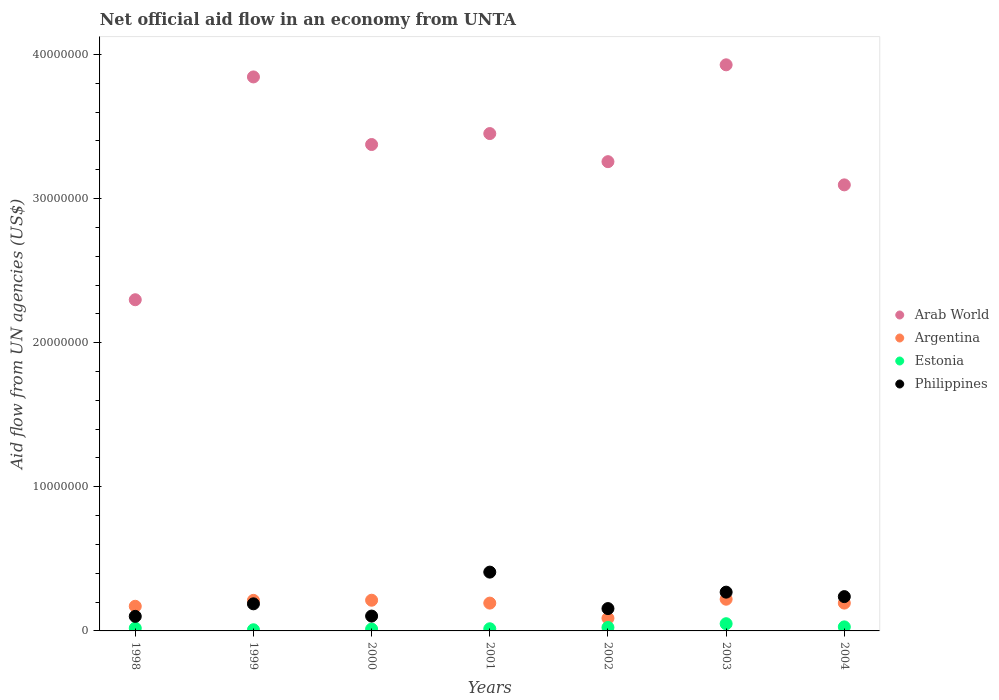Is the number of dotlines equal to the number of legend labels?
Offer a very short reply. Yes. What is the net official aid flow in Arab World in 2000?
Offer a terse response. 3.38e+07. Across all years, what is the maximum net official aid flow in Arab World?
Offer a terse response. 3.93e+07. In which year was the net official aid flow in Arab World maximum?
Ensure brevity in your answer.  2003. In which year was the net official aid flow in Estonia minimum?
Offer a terse response. 1999. What is the total net official aid flow in Argentina in the graph?
Your answer should be compact. 1.29e+07. What is the difference between the net official aid flow in Argentina in 1999 and that in 2001?
Ensure brevity in your answer.  1.90e+05. What is the difference between the net official aid flow in Philippines in 2002 and the net official aid flow in Argentina in 2003?
Make the answer very short. -6.50e+05. What is the average net official aid flow in Argentina per year?
Give a very brief answer. 1.84e+06. In the year 2000, what is the difference between the net official aid flow in Argentina and net official aid flow in Philippines?
Your response must be concise. 1.10e+06. In how many years, is the net official aid flow in Estonia greater than 6000000 US$?
Provide a short and direct response. 0. What is the ratio of the net official aid flow in Argentina in 2001 to that in 2003?
Keep it short and to the point. 0.88. Is the difference between the net official aid flow in Argentina in 1999 and 2001 greater than the difference between the net official aid flow in Philippines in 1999 and 2001?
Offer a terse response. Yes. What is the difference between the highest and the second highest net official aid flow in Philippines?
Keep it short and to the point. 1.39e+06. What is the difference between the highest and the lowest net official aid flow in Philippines?
Give a very brief answer. 3.07e+06. In how many years, is the net official aid flow in Arab World greater than the average net official aid flow in Arab World taken over all years?
Ensure brevity in your answer.  4. Is the net official aid flow in Arab World strictly greater than the net official aid flow in Argentina over the years?
Provide a short and direct response. Yes. Are the values on the major ticks of Y-axis written in scientific E-notation?
Offer a terse response. No. Does the graph contain grids?
Give a very brief answer. No. How many legend labels are there?
Provide a succinct answer. 4. What is the title of the graph?
Your answer should be compact. Net official aid flow in an economy from UNTA. What is the label or title of the Y-axis?
Make the answer very short. Aid flow from UN agencies (US$). What is the Aid flow from UN agencies (US$) of Arab World in 1998?
Provide a short and direct response. 2.30e+07. What is the Aid flow from UN agencies (US$) of Argentina in 1998?
Offer a terse response. 1.71e+06. What is the Aid flow from UN agencies (US$) of Philippines in 1998?
Ensure brevity in your answer.  1.01e+06. What is the Aid flow from UN agencies (US$) in Arab World in 1999?
Provide a succinct answer. 3.84e+07. What is the Aid flow from UN agencies (US$) in Argentina in 1999?
Your response must be concise. 2.12e+06. What is the Aid flow from UN agencies (US$) in Philippines in 1999?
Your response must be concise. 1.88e+06. What is the Aid flow from UN agencies (US$) of Arab World in 2000?
Ensure brevity in your answer.  3.38e+07. What is the Aid flow from UN agencies (US$) in Argentina in 2000?
Provide a succinct answer. 2.13e+06. What is the Aid flow from UN agencies (US$) of Philippines in 2000?
Make the answer very short. 1.03e+06. What is the Aid flow from UN agencies (US$) of Arab World in 2001?
Make the answer very short. 3.45e+07. What is the Aid flow from UN agencies (US$) in Argentina in 2001?
Provide a succinct answer. 1.93e+06. What is the Aid flow from UN agencies (US$) in Estonia in 2001?
Provide a succinct answer. 1.50e+05. What is the Aid flow from UN agencies (US$) in Philippines in 2001?
Provide a short and direct response. 4.08e+06. What is the Aid flow from UN agencies (US$) in Arab World in 2002?
Make the answer very short. 3.26e+07. What is the Aid flow from UN agencies (US$) in Argentina in 2002?
Make the answer very short. 8.80e+05. What is the Aid flow from UN agencies (US$) of Philippines in 2002?
Offer a terse response. 1.55e+06. What is the Aid flow from UN agencies (US$) of Arab World in 2003?
Offer a terse response. 3.93e+07. What is the Aid flow from UN agencies (US$) of Argentina in 2003?
Provide a short and direct response. 2.20e+06. What is the Aid flow from UN agencies (US$) in Philippines in 2003?
Provide a short and direct response. 2.69e+06. What is the Aid flow from UN agencies (US$) of Arab World in 2004?
Offer a very short reply. 3.10e+07. What is the Aid flow from UN agencies (US$) in Argentina in 2004?
Provide a succinct answer. 1.93e+06. What is the Aid flow from UN agencies (US$) in Estonia in 2004?
Offer a terse response. 2.80e+05. What is the Aid flow from UN agencies (US$) of Philippines in 2004?
Your answer should be compact. 2.38e+06. Across all years, what is the maximum Aid flow from UN agencies (US$) of Arab World?
Ensure brevity in your answer.  3.93e+07. Across all years, what is the maximum Aid flow from UN agencies (US$) in Argentina?
Make the answer very short. 2.20e+06. Across all years, what is the maximum Aid flow from UN agencies (US$) of Philippines?
Provide a short and direct response. 4.08e+06. Across all years, what is the minimum Aid flow from UN agencies (US$) in Arab World?
Your answer should be very brief. 2.30e+07. Across all years, what is the minimum Aid flow from UN agencies (US$) of Argentina?
Provide a short and direct response. 8.80e+05. Across all years, what is the minimum Aid flow from UN agencies (US$) of Estonia?
Keep it short and to the point. 8.00e+04. Across all years, what is the minimum Aid flow from UN agencies (US$) in Philippines?
Make the answer very short. 1.01e+06. What is the total Aid flow from UN agencies (US$) of Arab World in the graph?
Make the answer very short. 2.32e+08. What is the total Aid flow from UN agencies (US$) of Argentina in the graph?
Your answer should be very brief. 1.29e+07. What is the total Aid flow from UN agencies (US$) in Estonia in the graph?
Offer a very short reply. 1.57e+06. What is the total Aid flow from UN agencies (US$) of Philippines in the graph?
Provide a succinct answer. 1.46e+07. What is the difference between the Aid flow from UN agencies (US$) in Arab World in 1998 and that in 1999?
Offer a terse response. -1.55e+07. What is the difference between the Aid flow from UN agencies (US$) in Argentina in 1998 and that in 1999?
Provide a short and direct response. -4.10e+05. What is the difference between the Aid flow from UN agencies (US$) of Philippines in 1998 and that in 1999?
Your answer should be very brief. -8.70e+05. What is the difference between the Aid flow from UN agencies (US$) of Arab World in 1998 and that in 2000?
Give a very brief answer. -1.08e+07. What is the difference between the Aid flow from UN agencies (US$) of Argentina in 1998 and that in 2000?
Give a very brief answer. -4.20e+05. What is the difference between the Aid flow from UN agencies (US$) of Philippines in 1998 and that in 2000?
Keep it short and to the point. -2.00e+04. What is the difference between the Aid flow from UN agencies (US$) in Arab World in 1998 and that in 2001?
Give a very brief answer. -1.15e+07. What is the difference between the Aid flow from UN agencies (US$) of Philippines in 1998 and that in 2001?
Your answer should be very brief. -3.07e+06. What is the difference between the Aid flow from UN agencies (US$) in Arab World in 1998 and that in 2002?
Give a very brief answer. -9.58e+06. What is the difference between the Aid flow from UN agencies (US$) of Argentina in 1998 and that in 2002?
Make the answer very short. 8.30e+05. What is the difference between the Aid flow from UN agencies (US$) in Estonia in 1998 and that in 2002?
Provide a short and direct response. -5.00e+04. What is the difference between the Aid flow from UN agencies (US$) of Philippines in 1998 and that in 2002?
Keep it short and to the point. -5.40e+05. What is the difference between the Aid flow from UN agencies (US$) of Arab World in 1998 and that in 2003?
Your answer should be compact. -1.63e+07. What is the difference between the Aid flow from UN agencies (US$) of Argentina in 1998 and that in 2003?
Give a very brief answer. -4.90e+05. What is the difference between the Aid flow from UN agencies (US$) in Estonia in 1998 and that in 2003?
Your answer should be very brief. -3.10e+05. What is the difference between the Aid flow from UN agencies (US$) of Philippines in 1998 and that in 2003?
Provide a succinct answer. -1.68e+06. What is the difference between the Aid flow from UN agencies (US$) in Arab World in 1998 and that in 2004?
Keep it short and to the point. -7.97e+06. What is the difference between the Aid flow from UN agencies (US$) of Argentina in 1998 and that in 2004?
Provide a succinct answer. -2.20e+05. What is the difference between the Aid flow from UN agencies (US$) of Estonia in 1998 and that in 2004?
Give a very brief answer. -9.00e+04. What is the difference between the Aid flow from UN agencies (US$) of Philippines in 1998 and that in 2004?
Ensure brevity in your answer.  -1.37e+06. What is the difference between the Aid flow from UN agencies (US$) of Arab World in 1999 and that in 2000?
Provide a short and direct response. 4.69e+06. What is the difference between the Aid flow from UN agencies (US$) in Philippines in 1999 and that in 2000?
Offer a terse response. 8.50e+05. What is the difference between the Aid flow from UN agencies (US$) of Arab World in 1999 and that in 2001?
Offer a terse response. 3.93e+06. What is the difference between the Aid flow from UN agencies (US$) of Argentina in 1999 and that in 2001?
Provide a short and direct response. 1.90e+05. What is the difference between the Aid flow from UN agencies (US$) of Philippines in 1999 and that in 2001?
Offer a very short reply. -2.20e+06. What is the difference between the Aid flow from UN agencies (US$) in Arab World in 1999 and that in 2002?
Make the answer very short. 5.88e+06. What is the difference between the Aid flow from UN agencies (US$) in Argentina in 1999 and that in 2002?
Keep it short and to the point. 1.24e+06. What is the difference between the Aid flow from UN agencies (US$) in Estonia in 1999 and that in 2002?
Offer a terse response. -1.60e+05. What is the difference between the Aid flow from UN agencies (US$) of Arab World in 1999 and that in 2003?
Provide a succinct answer. -8.40e+05. What is the difference between the Aid flow from UN agencies (US$) in Estonia in 1999 and that in 2003?
Your answer should be very brief. -4.20e+05. What is the difference between the Aid flow from UN agencies (US$) in Philippines in 1999 and that in 2003?
Ensure brevity in your answer.  -8.10e+05. What is the difference between the Aid flow from UN agencies (US$) in Arab World in 1999 and that in 2004?
Make the answer very short. 7.49e+06. What is the difference between the Aid flow from UN agencies (US$) in Argentina in 1999 and that in 2004?
Offer a very short reply. 1.90e+05. What is the difference between the Aid flow from UN agencies (US$) in Philippines in 1999 and that in 2004?
Offer a terse response. -5.00e+05. What is the difference between the Aid flow from UN agencies (US$) in Arab World in 2000 and that in 2001?
Ensure brevity in your answer.  -7.60e+05. What is the difference between the Aid flow from UN agencies (US$) of Estonia in 2000 and that in 2001?
Offer a terse response. -2.00e+04. What is the difference between the Aid flow from UN agencies (US$) of Philippines in 2000 and that in 2001?
Offer a terse response. -3.05e+06. What is the difference between the Aid flow from UN agencies (US$) in Arab World in 2000 and that in 2002?
Keep it short and to the point. 1.19e+06. What is the difference between the Aid flow from UN agencies (US$) in Argentina in 2000 and that in 2002?
Your response must be concise. 1.25e+06. What is the difference between the Aid flow from UN agencies (US$) of Estonia in 2000 and that in 2002?
Offer a terse response. -1.10e+05. What is the difference between the Aid flow from UN agencies (US$) of Philippines in 2000 and that in 2002?
Make the answer very short. -5.20e+05. What is the difference between the Aid flow from UN agencies (US$) in Arab World in 2000 and that in 2003?
Ensure brevity in your answer.  -5.53e+06. What is the difference between the Aid flow from UN agencies (US$) of Estonia in 2000 and that in 2003?
Provide a succinct answer. -3.70e+05. What is the difference between the Aid flow from UN agencies (US$) of Philippines in 2000 and that in 2003?
Keep it short and to the point. -1.66e+06. What is the difference between the Aid flow from UN agencies (US$) in Arab World in 2000 and that in 2004?
Your response must be concise. 2.80e+06. What is the difference between the Aid flow from UN agencies (US$) in Estonia in 2000 and that in 2004?
Make the answer very short. -1.50e+05. What is the difference between the Aid flow from UN agencies (US$) of Philippines in 2000 and that in 2004?
Offer a very short reply. -1.35e+06. What is the difference between the Aid flow from UN agencies (US$) in Arab World in 2001 and that in 2002?
Your answer should be compact. 1.95e+06. What is the difference between the Aid flow from UN agencies (US$) in Argentina in 2001 and that in 2002?
Ensure brevity in your answer.  1.05e+06. What is the difference between the Aid flow from UN agencies (US$) in Philippines in 2001 and that in 2002?
Provide a short and direct response. 2.53e+06. What is the difference between the Aid flow from UN agencies (US$) in Arab World in 2001 and that in 2003?
Ensure brevity in your answer.  -4.77e+06. What is the difference between the Aid flow from UN agencies (US$) of Argentina in 2001 and that in 2003?
Make the answer very short. -2.70e+05. What is the difference between the Aid flow from UN agencies (US$) of Estonia in 2001 and that in 2003?
Provide a short and direct response. -3.50e+05. What is the difference between the Aid flow from UN agencies (US$) of Philippines in 2001 and that in 2003?
Your answer should be very brief. 1.39e+06. What is the difference between the Aid flow from UN agencies (US$) in Arab World in 2001 and that in 2004?
Provide a succinct answer. 3.56e+06. What is the difference between the Aid flow from UN agencies (US$) in Argentina in 2001 and that in 2004?
Provide a short and direct response. 0. What is the difference between the Aid flow from UN agencies (US$) of Philippines in 2001 and that in 2004?
Your answer should be compact. 1.70e+06. What is the difference between the Aid flow from UN agencies (US$) in Arab World in 2002 and that in 2003?
Make the answer very short. -6.72e+06. What is the difference between the Aid flow from UN agencies (US$) of Argentina in 2002 and that in 2003?
Ensure brevity in your answer.  -1.32e+06. What is the difference between the Aid flow from UN agencies (US$) in Estonia in 2002 and that in 2003?
Give a very brief answer. -2.60e+05. What is the difference between the Aid flow from UN agencies (US$) of Philippines in 2002 and that in 2003?
Provide a succinct answer. -1.14e+06. What is the difference between the Aid flow from UN agencies (US$) in Arab World in 2002 and that in 2004?
Your response must be concise. 1.61e+06. What is the difference between the Aid flow from UN agencies (US$) of Argentina in 2002 and that in 2004?
Offer a terse response. -1.05e+06. What is the difference between the Aid flow from UN agencies (US$) in Philippines in 2002 and that in 2004?
Ensure brevity in your answer.  -8.30e+05. What is the difference between the Aid flow from UN agencies (US$) of Arab World in 2003 and that in 2004?
Ensure brevity in your answer.  8.33e+06. What is the difference between the Aid flow from UN agencies (US$) in Estonia in 2003 and that in 2004?
Your answer should be compact. 2.20e+05. What is the difference between the Aid flow from UN agencies (US$) in Philippines in 2003 and that in 2004?
Offer a very short reply. 3.10e+05. What is the difference between the Aid flow from UN agencies (US$) in Arab World in 1998 and the Aid flow from UN agencies (US$) in Argentina in 1999?
Your response must be concise. 2.09e+07. What is the difference between the Aid flow from UN agencies (US$) of Arab World in 1998 and the Aid flow from UN agencies (US$) of Estonia in 1999?
Make the answer very short. 2.29e+07. What is the difference between the Aid flow from UN agencies (US$) in Arab World in 1998 and the Aid flow from UN agencies (US$) in Philippines in 1999?
Your response must be concise. 2.11e+07. What is the difference between the Aid flow from UN agencies (US$) of Argentina in 1998 and the Aid flow from UN agencies (US$) of Estonia in 1999?
Your response must be concise. 1.63e+06. What is the difference between the Aid flow from UN agencies (US$) in Argentina in 1998 and the Aid flow from UN agencies (US$) in Philippines in 1999?
Give a very brief answer. -1.70e+05. What is the difference between the Aid flow from UN agencies (US$) in Estonia in 1998 and the Aid flow from UN agencies (US$) in Philippines in 1999?
Make the answer very short. -1.69e+06. What is the difference between the Aid flow from UN agencies (US$) in Arab World in 1998 and the Aid flow from UN agencies (US$) in Argentina in 2000?
Your answer should be very brief. 2.08e+07. What is the difference between the Aid flow from UN agencies (US$) in Arab World in 1998 and the Aid flow from UN agencies (US$) in Estonia in 2000?
Your answer should be compact. 2.28e+07. What is the difference between the Aid flow from UN agencies (US$) of Arab World in 1998 and the Aid flow from UN agencies (US$) of Philippines in 2000?
Your answer should be compact. 2.20e+07. What is the difference between the Aid flow from UN agencies (US$) of Argentina in 1998 and the Aid flow from UN agencies (US$) of Estonia in 2000?
Your response must be concise. 1.58e+06. What is the difference between the Aid flow from UN agencies (US$) of Argentina in 1998 and the Aid flow from UN agencies (US$) of Philippines in 2000?
Your answer should be compact. 6.80e+05. What is the difference between the Aid flow from UN agencies (US$) of Estonia in 1998 and the Aid flow from UN agencies (US$) of Philippines in 2000?
Make the answer very short. -8.40e+05. What is the difference between the Aid flow from UN agencies (US$) in Arab World in 1998 and the Aid flow from UN agencies (US$) in Argentina in 2001?
Offer a very short reply. 2.10e+07. What is the difference between the Aid flow from UN agencies (US$) of Arab World in 1998 and the Aid flow from UN agencies (US$) of Estonia in 2001?
Keep it short and to the point. 2.28e+07. What is the difference between the Aid flow from UN agencies (US$) of Arab World in 1998 and the Aid flow from UN agencies (US$) of Philippines in 2001?
Give a very brief answer. 1.89e+07. What is the difference between the Aid flow from UN agencies (US$) in Argentina in 1998 and the Aid flow from UN agencies (US$) in Estonia in 2001?
Keep it short and to the point. 1.56e+06. What is the difference between the Aid flow from UN agencies (US$) in Argentina in 1998 and the Aid flow from UN agencies (US$) in Philippines in 2001?
Your response must be concise. -2.37e+06. What is the difference between the Aid flow from UN agencies (US$) in Estonia in 1998 and the Aid flow from UN agencies (US$) in Philippines in 2001?
Your response must be concise. -3.89e+06. What is the difference between the Aid flow from UN agencies (US$) in Arab World in 1998 and the Aid flow from UN agencies (US$) in Argentina in 2002?
Keep it short and to the point. 2.21e+07. What is the difference between the Aid flow from UN agencies (US$) of Arab World in 1998 and the Aid flow from UN agencies (US$) of Estonia in 2002?
Provide a succinct answer. 2.27e+07. What is the difference between the Aid flow from UN agencies (US$) of Arab World in 1998 and the Aid flow from UN agencies (US$) of Philippines in 2002?
Offer a terse response. 2.14e+07. What is the difference between the Aid flow from UN agencies (US$) of Argentina in 1998 and the Aid flow from UN agencies (US$) of Estonia in 2002?
Give a very brief answer. 1.47e+06. What is the difference between the Aid flow from UN agencies (US$) of Estonia in 1998 and the Aid flow from UN agencies (US$) of Philippines in 2002?
Give a very brief answer. -1.36e+06. What is the difference between the Aid flow from UN agencies (US$) in Arab World in 1998 and the Aid flow from UN agencies (US$) in Argentina in 2003?
Your answer should be very brief. 2.08e+07. What is the difference between the Aid flow from UN agencies (US$) of Arab World in 1998 and the Aid flow from UN agencies (US$) of Estonia in 2003?
Your response must be concise. 2.25e+07. What is the difference between the Aid flow from UN agencies (US$) of Arab World in 1998 and the Aid flow from UN agencies (US$) of Philippines in 2003?
Provide a succinct answer. 2.03e+07. What is the difference between the Aid flow from UN agencies (US$) in Argentina in 1998 and the Aid flow from UN agencies (US$) in Estonia in 2003?
Keep it short and to the point. 1.21e+06. What is the difference between the Aid flow from UN agencies (US$) in Argentina in 1998 and the Aid flow from UN agencies (US$) in Philippines in 2003?
Your answer should be very brief. -9.80e+05. What is the difference between the Aid flow from UN agencies (US$) in Estonia in 1998 and the Aid flow from UN agencies (US$) in Philippines in 2003?
Your answer should be very brief. -2.50e+06. What is the difference between the Aid flow from UN agencies (US$) in Arab World in 1998 and the Aid flow from UN agencies (US$) in Argentina in 2004?
Keep it short and to the point. 2.10e+07. What is the difference between the Aid flow from UN agencies (US$) in Arab World in 1998 and the Aid flow from UN agencies (US$) in Estonia in 2004?
Offer a very short reply. 2.27e+07. What is the difference between the Aid flow from UN agencies (US$) in Arab World in 1998 and the Aid flow from UN agencies (US$) in Philippines in 2004?
Your answer should be compact. 2.06e+07. What is the difference between the Aid flow from UN agencies (US$) in Argentina in 1998 and the Aid flow from UN agencies (US$) in Estonia in 2004?
Give a very brief answer. 1.43e+06. What is the difference between the Aid flow from UN agencies (US$) of Argentina in 1998 and the Aid flow from UN agencies (US$) of Philippines in 2004?
Offer a terse response. -6.70e+05. What is the difference between the Aid flow from UN agencies (US$) of Estonia in 1998 and the Aid flow from UN agencies (US$) of Philippines in 2004?
Your answer should be very brief. -2.19e+06. What is the difference between the Aid flow from UN agencies (US$) of Arab World in 1999 and the Aid flow from UN agencies (US$) of Argentina in 2000?
Make the answer very short. 3.63e+07. What is the difference between the Aid flow from UN agencies (US$) of Arab World in 1999 and the Aid flow from UN agencies (US$) of Estonia in 2000?
Provide a short and direct response. 3.83e+07. What is the difference between the Aid flow from UN agencies (US$) of Arab World in 1999 and the Aid flow from UN agencies (US$) of Philippines in 2000?
Your answer should be very brief. 3.74e+07. What is the difference between the Aid flow from UN agencies (US$) in Argentina in 1999 and the Aid flow from UN agencies (US$) in Estonia in 2000?
Your answer should be compact. 1.99e+06. What is the difference between the Aid flow from UN agencies (US$) in Argentina in 1999 and the Aid flow from UN agencies (US$) in Philippines in 2000?
Keep it short and to the point. 1.09e+06. What is the difference between the Aid flow from UN agencies (US$) in Estonia in 1999 and the Aid flow from UN agencies (US$) in Philippines in 2000?
Offer a very short reply. -9.50e+05. What is the difference between the Aid flow from UN agencies (US$) in Arab World in 1999 and the Aid flow from UN agencies (US$) in Argentina in 2001?
Provide a succinct answer. 3.65e+07. What is the difference between the Aid flow from UN agencies (US$) of Arab World in 1999 and the Aid flow from UN agencies (US$) of Estonia in 2001?
Your answer should be very brief. 3.83e+07. What is the difference between the Aid flow from UN agencies (US$) in Arab World in 1999 and the Aid flow from UN agencies (US$) in Philippines in 2001?
Offer a very short reply. 3.44e+07. What is the difference between the Aid flow from UN agencies (US$) of Argentina in 1999 and the Aid flow from UN agencies (US$) of Estonia in 2001?
Offer a very short reply. 1.97e+06. What is the difference between the Aid flow from UN agencies (US$) of Argentina in 1999 and the Aid flow from UN agencies (US$) of Philippines in 2001?
Offer a terse response. -1.96e+06. What is the difference between the Aid flow from UN agencies (US$) of Arab World in 1999 and the Aid flow from UN agencies (US$) of Argentina in 2002?
Provide a succinct answer. 3.76e+07. What is the difference between the Aid flow from UN agencies (US$) of Arab World in 1999 and the Aid flow from UN agencies (US$) of Estonia in 2002?
Offer a terse response. 3.82e+07. What is the difference between the Aid flow from UN agencies (US$) of Arab World in 1999 and the Aid flow from UN agencies (US$) of Philippines in 2002?
Ensure brevity in your answer.  3.69e+07. What is the difference between the Aid flow from UN agencies (US$) of Argentina in 1999 and the Aid flow from UN agencies (US$) of Estonia in 2002?
Provide a short and direct response. 1.88e+06. What is the difference between the Aid flow from UN agencies (US$) of Argentina in 1999 and the Aid flow from UN agencies (US$) of Philippines in 2002?
Ensure brevity in your answer.  5.70e+05. What is the difference between the Aid flow from UN agencies (US$) of Estonia in 1999 and the Aid flow from UN agencies (US$) of Philippines in 2002?
Give a very brief answer. -1.47e+06. What is the difference between the Aid flow from UN agencies (US$) of Arab World in 1999 and the Aid flow from UN agencies (US$) of Argentina in 2003?
Make the answer very short. 3.62e+07. What is the difference between the Aid flow from UN agencies (US$) in Arab World in 1999 and the Aid flow from UN agencies (US$) in Estonia in 2003?
Your answer should be compact. 3.79e+07. What is the difference between the Aid flow from UN agencies (US$) in Arab World in 1999 and the Aid flow from UN agencies (US$) in Philippines in 2003?
Offer a terse response. 3.58e+07. What is the difference between the Aid flow from UN agencies (US$) of Argentina in 1999 and the Aid flow from UN agencies (US$) of Estonia in 2003?
Your answer should be very brief. 1.62e+06. What is the difference between the Aid flow from UN agencies (US$) in Argentina in 1999 and the Aid flow from UN agencies (US$) in Philippines in 2003?
Keep it short and to the point. -5.70e+05. What is the difference between the Aid flow from UN agencies (US$) in Estonia in 1999 and the Aid flow from UN agencies (US$) in Philippines in 2003?
Your response must be concise. -2.61e+06. What is the difference between the Aid flow from UN agencies (US$) in Arab World in 1999 and the Aid flow from UN agencies (US$) in Argentina in 2004?
Your answer should be compact. 3.65e+07. What is the difference between the Aid flow from UN agencies (US$) of Arab World in 1999 and the Aid flow from UN agencies (US$) of Estonia in 2004?
Provide a succinct answer. 3.82e+07. What is the difference between the Aid flow from UN agencies (US$) of Arab World in 1999 and the Aid flow from UN agencies (US$) of Philippines in 2004?
Ensure brevity in your answer.  3.61e+07. What is the difference between the Aid flow from UN agencies (US$) of Argentina in 1999 and the Aid flow from UN agencies (US$) of Estonia in 2004?
Ensure brevity in your answer.  1.84e+06. What is the difference between the Aid flow from UN agencies (US$) of Argentina in 1999 and the Aid flow from UN agencies (US$) of Philippines in 2004?
Your answer should be very brief. -2.60e+05. What is the difference between the Aid flow from UN agencies (US$) of Estonia in 1999 and the Aid flow from UN agencies (US$) of Philippines in 2004?
Keep it short and to the point. -2.30e+06. What is the difference between the Aid flow from UN agencies (US$) of Arab World in 2000 and the Aid flow from UN agencies (US$) of Argentina in 2001?
Give a very brief answer. 3.18e+07. What is the difference between the Aid flow from UN agencies (US$) in Arab World in 2000 and the Aid flow from UN agencies (US$) in Estonia in 2001?
Offer a terse response. 3.36e+07. What is the difference between the Aid flow from UN agencies (US$) in Arab World in 2000 and the Aid flow from UN agencies (US$) in Philippines in 2001?
Your answer should be very brief. 2.97e+07. What is the difference between the Aid flow from UN agencies (US$) in Argentina in 2000 and the Aid flow from UN agencies (US$) in Estonia in 2001?
Ensure brevity in your answer.  1.98e+06. What is the difference between the Aid flow from UN agencies (US$) in Argentina in 2000 and the Aid flow from UN agencies (US$) in Philippines in 2001?
Provide a short and direct response. -1.95e+06. What is the difference between the Aid flow from UN agencies (US$) in Estonia in 2000 and the Aid flow from UN agencies (US$) in Philippines in 2001?
Your answer should be compact. -3.95e+06. What is the difference between the Aid flow from UN agencies (US$) of Arab World in 2000 and the Aid flow from UN agencies (US$) of Argentina in 2002?
Ensure brevity in your answer.  3.29e+07. What is the difference between the Aid flow from UN agencies (US$) in Arab World in 2000 and the Aid flow from UN agencies (US$) in Estonia in 2002?
Offer a very short reply. 3.35e+07. What is the difference between the Aid flow from UN agencies (US$) of Arab World in 2000 and the Aid flow from UN agencies (US$) of Philippines in 2002?
Offer a very short reply. 3.22e+07. What is the difference between the Aid flow from UN agencies (US$) in Argentina in 2000 and the Aid flow from UN agencies (US$) in Estonia in 2002?
Offer a very short reply. 1.89e+06. What is the difference between the Aid flow from UN agencies (US$) of Argentina in 2000 and the Aid flow from UN agencies (US$) of Philippines in 2002?
Provide a succinct answer. 5.80e+05. What is the difference between the Aid flow from UN agencies (US$) in Estonia in 2000 and the Aid flow from UN agencies (US$) in Philippines in 2002?
Your answer should be compact. -1.42e+06. What is the difference between the Aid flow from UN agencies (US$) in Arab World in 2000 and the Aid flow from UN agencies (US$) in Argentina in 2003?
Your answer should be compact. 3.16e+07. What is the difference between the Aid flow from UN agencies (US$) in Arab World in 2000 and the Aid flow from UN agencies (US$) in Estonia in 2003?
Offer a very short reply. 3.32e+07. What is the difference between the Aid flow from UN agencies (US$) in Arab World in 2000 and the Aid flow from UN agencies (US$) in Philippines in 2003?
Provide a succinct answer. 3.11e+07. What is the difference between the Aid flow from UN agencies (US$) of Argentina in 2000 and the Aid flow from UN agencies (US$) of Estonia in 2003?
Give a very brief answer. 1.63e+06. What is the difference between the Aid flow from UN agencies (US$) in Argentina in 2000 and the Aid flow from UN agencies (US$) in Philippines in 2003?
Your answer should be very brief. -5.60e+05. What is the difference between the Aid flow from UN agencies (US$) of Estonia in 2000 and the Aid flow from UN agencies (US$) of Philippines in 2003?
Provide a succinct answer. -2.56e+06. What is the difference between the Aid flow from UN agencies (US$) of Arab World in 2000 and the Aid flow from UN agencies (US$) of Argentina in 2004?
Give a very brief answer. 3.18e+07. What is the difference between the Aid flow from UN agencies (US$) of Arab World in 2000 and the Aid flow from UN agencies (US$) of Estonia in 2004?
Provide a short and direct response. 3.35e+07. What is the difference between the Aid flow from UN agencies (US$) in Arab World in 2000 and the Aid flow from UN agencies (US$) in Philippines in 2004?
Your response must be concise. 3.14e+07. What is the difference between the Aid flow from UN agencies (US$) of Argentina in 2000 and the Aid flow from UN agencies (US$) of Estonia in 2004?
Ensure brevity in your answer.  1.85e+06. What is the difference between the Aid flow from UN agencies (US$) of Estonia in 2000 and the Aid flow from UN agencies (US$) of Philippines in 2004?
Give a very brief answer. -2.25e+06. What is the difference between the Aid flow from UN agencies (US$) in Arab World in 2001 and the Aid flow from UN agencies (US$) in Argentina in 2002?
Offer a very short reply. 3.36e+07. What is the difference between the Aid flow from UN agencies (US$) in Arab World in 2001 and the Aid flow from UN agencies (US$) in Estonia in 2002?
Your answer should be compact. 3.43e+07. What is the difference between the Aid flow from UN agencies (US$) of Arab World in 2001 and the Aid flow from UN agencies (US$) of Philippines in 2002?
Offer a terse response. 3.30e+07. What is the difference between the Aid flow from UN agencies (US$) in Argentina in 2001 and the Aid flow from UN agencies (US$) in Estonia in 2002?
Offer a very short reply. 1.69e+06. What is the difference between the Aid flow from UN agencies (US$) of Estonia in 2001 and the Aid flow from UN agencies (US$) of Philippines in 2002?
Make the answer very short. -1.40e+06. What is the difference between the Aid flow from UN agencies (US$) of Arab World in 2001 and the Aid flow from UN agencies (US$) of Argentina in 2003?
Provide a succinct answer. 3.23e+07. What is the difference between the Aid flow from UN agencies (US$) in Arab World in 2001 and the Aid flow from UN agencies (US$) in Estonia in 2003?
Your answer should be very brief. 3.40e+07. What is the difference between the Aid flow from UN agencies (US$) of Arab World in 2001 and the Aid flow from UN agencies (US$) of Philippines in 2003?
Provide a succinct answer. 3.18e+07. What is the difference between the Aid flow from UN agencies (US$) in Argentina in 2001 and the Aid flow from UN agencies (US$) in Estonia in 2003?
Keep it short and to the point. 1.43e+06. What is the difference between the Aid flow from UN agencies (US$) of Argentina in 2001 and the Aid flow from UN agencies (US$) of Philippines in 2003?
Provide a succinct answer. -7.60e+05. What is the difference between the Aid flow from UN agencies (US$) of Estonia in 2001 and the Aid flow from UN agencies (US$) of Philippines in 2003?
Keep it short and to the point. -2.54e+06. What is the difference between the Aid flow from UN agencies (US$) in Arab World in 2001 and the Aid flow from UN agencies (US$) in Argentina in 2004?
Keep it short and to the point. 3.26e+07. What is the difference between the Aid flow from UN agencies (US$) of Arab World in 2001 and the Aid flow from UN agencies (US$) of Estonia in 2004?
Ensure brevity in your answer.  3.42e+07. What is the difference between the Aid flow from UN agencies (US$) of Arab World in 2001 and the Aid flow from UN agencies (US$) of Philippines in 2004?
Offer a terse response. 3.21e+07. What is the difference between the Aid flow from UN agencies (US$) of Argentina in 2001 and the Aid flow from UN agencies (US$) of Estonia in 2004?
Provide a short and direct response. 1.65e+06. What is the difference between the Aid flow from UN agencies (US$) in Argentina in 2001 and the Aid flow from UN agencies (US$) in Philippines in 2004?
Provide a succinct answer. -4.50e+05. What is the difference between the Aid flow from UN agencies (US$) of Estonia in 2001 and the Aid flow from UN agencies (US$) of Philippines in 2004?
Give a very brief answer. -2.23e+06. What is the difference between the Aid flow from UN agencies (US$) of Arab World in 2002 and the Aid flow from UN agencies (US$) of Argentina in 2003?
Offer a very short reply. 3.04e+07. What is the difference between the Aid flow from UN agencies (US$) of Arab World in 2002 and the Aid flow from UN agencies (US$) of Estonia in 2003?
Make the answer very short. 3.21e+07. What is the difference between the Aid flow from UN agencies (US$) in Arab World in 2002 and the Aid flow from UN agencies (US$) in Philippines in 2003?
Your response must be concise. 2.99e+07. What is the difference between the Aid flow from UN agencies (US$) of Argentina in 2002 and the Aid flow from UN agencies (US$) of Estonia in 2003?
Offer a terse response. 3.80e+05. What is the difference between the Aid flow from UN agencies (US$) of Argentina in 2002 and the Aid flow from UN agencies (US$) of Philippines in 2003?
Your response must be concise. -1.81e+06. What is the difference between the Aid flow from UN agencies (US$) in Estonia in 2002 and the Aid flow from UN agencies (US$) in Philippines in 2003?
Offer a terse response. -2.45e+06. What is the difference between the Aid flow from UN agencies (US$) in Arab World in 2002 and the Aid flow from UN agencies (US$) in Argentina in 2004?
Offer a terse response. 3.06e+07. What is the difference between the Aid flow from UN agencies (US$) of Arab World in 2002 and the Aid flow from UN agencies (US$) of Estonia in 2004?
Ensure brevity in your answer.  3.23e+07. What is the difference between the Aid flow from UN agencies (US$) of Arab World in 2002 and the Aid flow from UN agencies (US$) of Philippines in 2004?
Your response must be concise. 3.02e+07. What is the difference between the Aid flow from UN agencies (US$) of Argentina in 2002 and the Aid flow from UN agencies (US$) of Estonia in 2004?
Ensure brevity in your answer.  6.00e+05. What is the difference between the Aid flow from UN agencies (US$) of Argentina in 2002 and the Aid flow from UN agencies (US$) of Philippines in 2004?
Provide a short and direct response. -1.50e+06. What is the difference between the Aid flow from UN agencies (US$) in Estonia in 2002 and the Aid flow from UN agencies (US$) in Philippines in 2004?
Give a very brief answer. -2.14e+06. What is the difference between the Aid flow from UN agencies (US$) in Arab World in 2003 and the Aid flow from UN agencies (US$) in Argentina in 2004?
Offer a terse response. 3.74e+07. What is the difference between the Aid flow from UN agencies (US$) of Arab World in 2003 and the Aid flow from UN agencies (US$) of Estonia in 2004?
Your answer should be compact. 3.90e+07. What is the difference between the Aid flow from UN agencies (US$) in Arab World in 2003 and the Aid flow from UN agencies (US$) in Philippines in 2004?
Keep it short and to the point. 3.69e+07. What is the difference between the Aid flow from UN agencies (US$) in Argentina in 2003 and the Aid flow from UN agencies (US$) in Estonia in 2004?
Your response must be concise. 1.92e+06. What is the difference between the Aid flow from UN agencies (US$) of Argentina in 2003 and the Aid flow from UN agencies (US$) of Philippines in 2004?
Your answer should be very brief. -1.80e+05. What is the difference between the Aid flow from UN agencies (US$) in Estonia in 2003 and the Aid flow from UN agencies (US$) in Philippines in 2004?
Make the answer very short. -1.88e+06. What is the average Aid flow from UN agencies (US$) in Arab World per year?
Your answer should be compact. 3.32e+07. What is the average Aid flow from UN agencies (US$) of Argentina per year?
Offer a terse response. 1.84e+06. What is the average Aid flow from UN agencies (US$) in Estonia per year?
Make the answer very short. 2.24e+05. What is the average Aid flow from UN agencies (US$) of Philippines per year?
Your answer should be compact. 2.09e+06. In the year 1998, what is the difference between the Aid flow from UN agencies (US$) in Arab World and Aid flow from UN agencies (US$) in Argentina?
Provide a short and direct response. 2.13e+07. In the year 1998, what is the difference between the Aid flow from UN agencies (US$) of Arab World and Aid flow from UN agencies (US$) of Estonia?
Make the answer very short. 2.28e+07. In the year 1998, what is the difference between the Aid flow from UN agencies (US$) in Arab World and Aid flow from UN agencies (US$) in Philippines?
Provide a short and direct response. 2.20e+07. In the year 1998, what is the difference between the Aid flow from UN agencies (US$) in Argentina and Aid flow from UN agencies (US$) in Estonia?
Offer a very short reply. 1.52e+06. In the year 1998, what is the difference between the Aid flow from UN agencies (US$) in Argentina and Aid flow from UN agencies (US$) in Philippines?
Make the answer very short. 7.00e+05. In the year 1998, what is the difference between the Aid flow from UN agencies (US$) of Estonia and Aid flow from UN agencies (US$) of Philippines?
Your answer should be very brief. -8.20e+05. In the year 1999, what is the difference between the Aid flow from UN agencies (US$) of Arab World and Aid flow from UN agencies (US$) of Argentina?
Make the answer very short. 3.63e+07. In the year 1999, what is the difference between the Aid flow from UN agencies (US$) of Arab World and Aid flow from UN agencies (US$) of Estonia?
Provide a succinct answer. 3.84e+07. In the year 1999, what is the difference between the Aid flow from UN agencies (US$) in Arab World and Aid flow from UN agencies (US$) in Philippines?
Give a very brief answer. 3.66e+07. In the year 1999, what is the difference between the Aid flow from UN agencies (US$) in Argentina and Aid flow from UN agencies (US$) in Estonia?
Your response must be concise. 2.04e+06. In the year 1999, what is the difference between the Aid flow from UN agencies (US$) in Argentina and Aid flow from UN agencies (US$) in Philippines?
Make the answer very short. 2.40e+05. In the year 1999, what is the difference between the Aid flow from UN agencies (US$) of Estonia and Aid flow from UN agencies (US$) of Philippines?
Provide a short and direct response. -1.80e+06. In the year 2000, what is the difference between the Aid flow from UN agencies (US$) of Arab World and Aid flow from UN agencies (US$) of Argentina?
Keep it short and to the point. 3.16e+07. In the year 2000, what is the difference between the Aid flow from UN agencies (US$) of Arab World and Aid flow from UN agencies (US$) of Estonia?
Keep it short and to the point. 3.36e+07. In the year 2000, what is the difference between the Aid flow from UN agencies (US$) of Arab World and Aid flow from UN agencies (US$) of Philippines?
Make the answer very short. 3.27e+07. In the year 2000, what is the difference between the Aid flow from UN agencies (US$) of Argentina and Aid flow from UN agencies (US$) of Philippines?
Give a very brief answer. 1.10e+06. In the year 2000, what is the difference between the Aid flow from UN agencies (US$) in Estonia and Aid flow from UN agencies (US$) in Philippines?
Ensure brevity in your answer.  -9.00e+05. In the year 2001, what is the difference between the Aid flow from UN agencies (US$) of Arab World and Aid flow from UN agencies (US$) of Argentina?
Offer a terse response. 3.26e+07. In the year 2001, what is the difference between the Aid flow from UN agencies (US$) of Arab World and Aid flow from UN agencies (US$) of Estonia?
Your answer should be compact. 3.44e+07. In the year 2001, what is the difference between the Aid flow from UN agencies (US$) of Arab World and Aid flow from UN agencies (US$) of Philippines?
Provide a succinct answer. 3.04e+07. In the year 2001, what is the difference between the Aid flow from UN agencies (US$) in Argentina and Aid flow from UN agencies (US$) in Estonia?
Your answer should be compact. 1.78e+06. In the year 2001, what is the difference between the Aid flow from UN agencies (US$) in Argentina and Aid flow from UN agencies (US$) in Philippines?
Provide a succinct answer. -2.15e+06. In the year 2001, what is the difference between the Aid flow from UN agencies (US$) in Estonia and Aid flow from UN agencies (US$) in Philippines?
Keep it short and to the point. -3.93e+06. In the year 2002, what is the difference between the Aid flow from UN agencies (US$) in Arab World and Aid flow from UN agencies (US$) in Argentina?
Your answer should be compact. 3.17e+07. In the year 2002, what is the difference between the Aid flow from UN agencies (US$) in Arab World and Aid flow from UN agencies (US$) in Estonia?
Your answer should be compact. 3.23e+07. In the year 2002, what is the difference between the Aid flow from UN agencies (US$) in Arab World and Aid flow from UN agencies (US$) in Philippines?
Make the answer very short. 3.10e+07. In the year 2002, what is the difference between the Aid flow from UN agencies (US$) of Argentina and Aid flow from UN agencies (US$) of Estonia?
Offer a terse response. 6.40e+05. In the year 2002, what is the difference between the Aid flow from UN agencies (US$) in Argentina and Aid flow from UN agencies (US$) in Philippines?
Your answer should be compact. -6.70e+05. In the year 2002, what is the difference between the Aid flow from UN agencies (US$) of Estonia and Aid flow from UN agencies (US$) of Philippines?
Your response must be concise. -1.31e+06. In the year 2003, what is the difference between the Aid flow from UN agencies (US$) of Arab World and Aid flow from UN agencies (US$) of Argentina?
Offer a terse response. 3.71e+07. In the year 2003, what is the difference between the Aid flow from UN agencies (US$) of Arab World and Aid flow from UN agencies (US$) of Estonia?
Your answer should be very brief. 3.88e+07. In the year 2003, what is the difference between the Aid flow from UN agencies (US$) of Arab World and Aid flow from UN agencies (US$) of Philippines?
Offer a very short reply. 3.66e+07. In the year 2003, what is the difference between the Aid flow from UN agencies (US$) in Argentina and Aid flow from UN agencies (US$) in Estonia?
Provide a short and direct response. 1.70e+06. In the year 2003, what is the difference between the Aid flow from UN agencies (US$) of Argentina and Aid flow from UN agencies (US$) of Philippines?
Ensure brevity in your answer.  -4.90e+05. In the year 2003, what is the difference between the Aid flow from UN agencies (US$) in Estonia and Aid flow from UN agencies (US$) in Philippines?
Your response must be concise. -2.19e+06. In the year 2004, what is the difference between the Aid flow from UN agencies (US$) of Arab World and Aid flow from UN agencies (US$) of Argentina?
Offer a very short reply. 2.90e+07. In the year 2004, what is the difference between the Aid flow from UN agencies (US$) of Arab World and Aid flow from UN agencies (US$) of Estonia?
Offer a very short reply. 3.07e+07. In the year 2004, what is the difference between the Aid flow from UN agencies (US$) in Arab World and Aid flow from UN agencies (US$) in Philippines?
Give a very brief answer. 2.86e+07. In the year 2004, what is the difference between the Aid flow from UN agencies (US$) of Argentina and Aid flow from UN agencies (US$) of Estonia?
Your response must be concise. 1.65e+06. In the year 2004, what is the difference between the Aid flow from UN agencies (US$) of Argentina and Aid flow from UN agencies (US$) of Philippines?
Give a very brief answer. -4.50e+05. In the year 2004, what is the difference between the Aid flow from UN agencies (US$) in Estonia and Aid flow from UN agencies (US$) in Philippines?
Your response must be concise. -2.10e+06. What is the ratio of the Aid flow from UN agencies (US$) in Arab World in 1998 to that in 1999?
Make the answer very short. 0.6. What is the ratio of the Aid flow from UN agencies (US$) in Argentina in 1998 to that in 1999?
Make the answer very short. 0.81. What is the ratio of the Aid flow from UN agencies (US$) of Estonia in 1998 to that in 1999?
Offer a terse response. 2.38. What is the ratio of the Aid flow from UN agencies (US$) in Philippines in 1998 to that in 1999?
Your answer should be very brief. 0.54. What is the ratio of the Aid flow from UN agencies (US$) in Arab World in 1998 to that in 2000?
Ensure brevity in your answer.  0.68. What is the ratio of the Aid flow from UN agencies (US$) of Argentina in 1998 to that in 2000?
Make the answer very short. 0.8. What is the ratio of the Aid flow from UN agencies (US$) of Estonia in 1998 to that in 2000?
Your response must be concise. 1.46. What is the ratio of the Aid flow from UN agencies (US$) of Philippines in 1998 to that in 2000?
Keep it short and to the point. 0.98. What is the ratio of the Aid flow from UN agencies (US$) of Arab World in 1998 to that in 2001?
Your response must be concise. 0.67. What is the ratio of the Aid flow from UN agencies (US$) in Argentina in 1998 to that in 2001?
Make the answer very short. 0.89. What is the ratio of the Aid flow from UN agencies (US$) in Estonia in 1998 to that in 2001?
Provide a short and direct response. 1.27. What is the ratio of the Aid flow from UN agencies (US$) in Philippines in 1998 to that in 2001?
Provide a succinct answer. 0.25. What is the ratio of the Aid flow from UN agencies (US$) of Arab World in 1998 to that in 2002?
Provide a succinct answer. 0.71. What is the ratio of the Aid flow from UN agencies (US$) of Argentina in 1998 to that in 2002?
Offer a terse response. 1.94. What is the ratio of the Aid flow from UN agencies (US$) of Estonia in 1998 to that in 2002?
Your answer should be very brief. 0.79. What is the ratio of the Aid flow from UN agencies (US$) in Philippines in 1998 to that in 2002?
Your answer should be very brief. 0.65. What is the ratio of the Aid flow from UN agencies (US$) in Arab World in 1998 to that in 2003?
Provide a succinct answer. 0.58. What is the ratio of the Aid flow from UN agencies (US$) of Argentina in 1998 to that in 2003?
Your answer should be compact. 0.78. What is the ratio of the Aid flow from UN agencies (US$) of Estonia in 1998 to that in 2003?
Your answer should be compact. 0.38. What is the ratio of the Aid flow from UN agencies (US$) of Philippines in 1998 to that in 2003?
Give a very brief answer. 0.38. What is the ratio of the Aid flow from UN agencies (US$) in Arab World in 1998 to that in 2004?
Offer a very short reply. 0.74. What is the ratio of the Aid flow from UN agencies (US$) in Argentina in 1998 to that in 2004?
Make the answer very short. 0.89. What is the ratio of the Aid flow from UN agencies (US$) of Estonia in 1998 to that in 2004?
Your answer should be compact. 0.68. What is the ratio of the Aid flow from UN agencies (US$) of Philippines in 1998 to that in 2004?
Give a very brief answer. 0.42. What is the ratio of the Aid flow from UN agencies (US$) in Arab World in 1999 to that in 2000?
Ensure brevity in your answer.  1.14. What is the ratio of the Aid flow from UN agencies (US$) of Argentina in 1999 to that in 2000?
Offer a terse response. 1. What is the ratio of the Aid flow from UN agencies (US$) of Estonia in 1999 to that in 2000?
Provide a short and direct response. 0.62. What is the ratio of the Aid flow from UN agencies (US$) of Philippines in 1999 to that in 2000?
Make the answer very short. 1.83. What is the ratio of the Aid flow from UN agencies (US$) in Arab World in 1999 to that in 2001?
Your response must be concise. 1.11. What is the ratio of the Aid flow from UN agencies (US$) in Argentina in 1999 to that in 2001?
Your response must be concise. 1.1. What is the ratio of the Aid flow from UN agencies (US$) in Estonia in 1999 to that in 2001?
Keep it short and to the point. 0.53. What is the ratio of the Aid flow from UN agencies (US$) in Philippines in 1999 to that in 2001?
Make the answer very short. 0.46. What is the ratio of the Aid flow from UN agencies (US$) in Arab World in 1999 to that in 2002?
Your response must be concise. 1.18. What is the ratio of the Aid flow from UN agencies (US$) of Argentina in 1999 to that in 2002?
Offer a terse response. 2.41. What is the ratio of the Aid flow from UN agencies (US$) of Estonia in 1999 to that in 2002?
Provide a succinct answer. 0.33. What is the ratio of the Aid flow from UN agencies (US$) in Philippines in 1999 to that in 2002?
Offer a very short reply. 1.21. What is the ratio of the Aid flow from UN agencies (US$) of Arab World in 1999 to that in 2003?
Your answer should be very brief. 0.98. What is the ratio of the Aid flow from UN agencies (US$) in Argentina in 1999 to that in 2003?
Your answer should be compact. 0.96. What is the ratio of the Aid flow from UN agencies (US$) of Estonia in 1999 to that in 2003?
Offer a very short reply. 0.16. What is the ratio of the Aid flow from UN agencies (US$) in Philippines in 1999 to that in 2003?
Offer a very short reply. 0.7. What is the ratio of the Aid flow from UN agencies (US$) of Arab World in 1999 to that in 2004?
Offer a terse response. 1.24. What is the ratio of the Aid flow from UN agencies (US$) in Argentina in 1999 to that in 2004?
Your response must be concise. 1.1. What is the ratio of the Aid flow from UN agencies (US$) in Estonia in 1999 to that in 2004?
Provide a short and direct response. 0.29. What is the ratio of the Aid flow from UN agencies (US$) in Philippines in 1999 to that in 2004?
Ensure brevity in your answer.  0.79. What is the ratio of the Aid flow from UN agencies (US$) in Arab World in 2000 to that in 2001?
Your answer should be compact. 0.98. What is the ratio of the Aid flow from UN agencies (US$) of Argentina in 2000 to that in 2001?
Offer a very short reply. 1.1. What is the ratio of the Aid flow from UN agencies (US$) of Estonia in 2000 to that in 2001?
Make the answer very short. 0.87. What is the ratio of the Aid flow from UN agencies (US$) in Philippines in 2000 to that in 2001?
Your answer should be very brief. 0.25. What is the ratio of the Aid flow from UN agencies (US$) of Arab World in 2000 to that in 2002?
Give a very brief answer. 1.04. What is the ratio of the Aid flow from UN agencies (US$) of Argentina in 2000 to that in 2002?
Ensure brevity in your answer.  2.42. What is the ratio of the Aid flow from UN agencies (US$) in Estonia in 2000 to that in 2002?
Your response must be concise. 0.54. What is the ratio of the Aid flow from UN agencies (US$) in Philippines in 2000 to that in 2002?
Provide a succinct answer. 0.66. What is the ratio of the Aid flow from UN agencies (US$) of Arab World in 2000 to that in 2003?
Offer a terse response. 0.86. What is the ratio of the Aid flow from UN agencies (US$) of Argentina in 2000 to that in 2003?
Provide a short and direct response. 0.97. What is the ratio of the Aid flow from UN agencies (US$) of Estonia in 2000 to that in 2003?
Ensure brevity in your answer.  0.26. What is the ratio of the Aid flow from UN agencies (US$) in Philippines in 2000 to that in 2003?
Offer a terse response. 0.38. What is the ratio of the Aid flow from UN agencies (US$) in Arab World in 2000 to that in 2004?
Offer a very short reply. 1.09. What is the ratio of the Aid flow from UN agencies (US$) of Argentina in 2000 to that in 2004?
Keep it short and to the point. 1.1. What is the ratio of the Aid flow from UN agencies (US$) in Estonia in 2000 to that in 2004?
Your answer should be very brief. 0.46. What is the ratio of the Aid flow from UN agencies (US$) of Philippines in 2000 to that in 2004?
Offer a terse response. 0.43. What is the ratio of the Aid flow from UN agencies (US$) of Arab World in 2001 to that in 2002?
Provide a succinct answer. 1.06. What is the ratio of the Aid flow from UN agencies (US$) in Argentina in 2001 to that in 2002?
Your answer should be very brief. 2.19. What is the ratio of the Aid flow from UN agencies (US$) in Estonia in 2001 to that in 2002?
Ensure brevity in your answer.  0.62. What is the ratio of the Aid flow from UN agencies (US$) in Philippines in 2001 to that in 2002?
Your answer should be very brief. 2.63. What is the ratio of the Aid flow from UN agencies (US$) of Arab World in 2001 to that in 2003?
Ensure brevity in your answer.  0.88. What is the ratio of the Aid flow from UN agencies (US$) in Argentina in 2001 to that in 2003?
Your answer should be very brief. 0.88. What is the ratio of the Aid flow from UN agencies (US$) in Philippines in 2001 to that in 2003?
Give a very brief answer. 1.52. What is the ratio of the Aid flow from UN agencies (US$) in Arab World in 2001 to that in 2004?
Keep it short and to the point. 1.11. What is the ratio of the Aid flow from UN agencies (US$) in Estonia in 2001 to that in 2004?
Provide a succinct answer. 0.54. What is the ratio of the Aid flow from UN agencies (US$) in Philippines in 2001 to that in 2004?
Keep it short and to the point. 1.71. What is the ratio of the Aid flow from UN agencies (US$) in Arab World in 2002 to that in 2003?
Offer a very short reply. 0.83. What is the ratio of the Aid flow from UN agencies (US$) in Argentina in 2002 to that in 2003?
Your answer should be compact. 0.4. What is the ratio of the Aid flow from UN agencies (US$) of Estonia in 2002 to that in 2003?
Provide a succinct answer. 0.48. What is the ratio of the Aid flow from UN agencies (US$) of Philippines in 2002 to that in 2003?
Your answer should be very brief. 0.58. What is the ratio of the Aid flow from UN agencies (US$) of Arab World in 2002 to that in 2004?
Provide a succinct answer. 1.05. What is the ratio of the Aid flow from UN agencies (US$) of Argentina in 2002 to that in 2004?
Provide a succinct answer. 0.46. What is the ratio of the Aid flow from UN agencies (US$) of Estonia in 2002 to that in 2004?
Your answer should be very brief. 0.86. What is the ratio of the Aid flow from UN agencies (US$) of Philippines in 2002 to that in 2004?
Your response must be concise. 0.65. What is the ratio of the Aid flow from UN agencies (US$) in Arab World in 2003 to that in 2004?
Keep it short and to the point. 1.27. What is the ratio of the Aid flow from UN agencies (US$) in Argentina in 2003 to that in 2004?
Ensure brevity in your answer.  1.14. What is the ratio of the Aid flow from UN agencies (US$) of Estonia in 2003 to that in 2004?
Ensure brevity in your answer.  1.79. What is the ratio of the Aid flow from UN agencies (US$) of Philippines in 2003 to that in 2004?
Make the answer very short. 1.13. What is the difference between the highest and the second highest Aid flow from UN agencies (US$) in Arab World?
Keep it short and to the point. 8.40e+05. What is the difference between the highest and the second highest Aid flow from UN agencies (US$) in Estonia?
Provide a short and direct response. 2.20e+05. What is the difference between the highest and the second highest Aid flow from UN agencies (US$) in Philippines?
Ensure brevity in your answer.  1.39e+06. What is the difference between the highest and the lowest Aid flow from UN agencies (US$) in Arab World?
Provide a succinct answer. 1.63e+07. What is the difference between the highest and the lowest Aid flow from UN agencies (US$) in Argentina?
Your answer should be very brief. 1.32e+06. What is the difference between the highest and the lowest Aid flow from UN agencies (US$) of Philippines?
Give a very brief answer. 3.07e+06. 